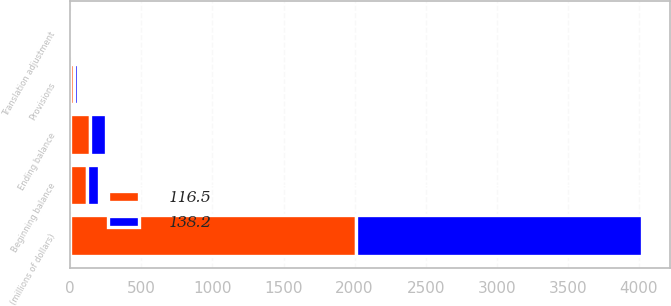Convert chart to OTSL. <chart><loc_0><loc_0><loc_500><loc_500><stacked_bar_chart><ecel><fcel>(millions of dollars)<fcel>Beginning balance<fcel>Provisions<fcel>Translation adjustment<fcel>Ending balance<nl><fcel>116.5<fcel>2010<fcel>116.5<fcel>28.4<fcel>6.7<fcel>138.2<nl><fcel>138.2<fcel>2009<fcel>82.8<fcel>26.3<fcel>2.8<fcel>116.5<nl></chart> 